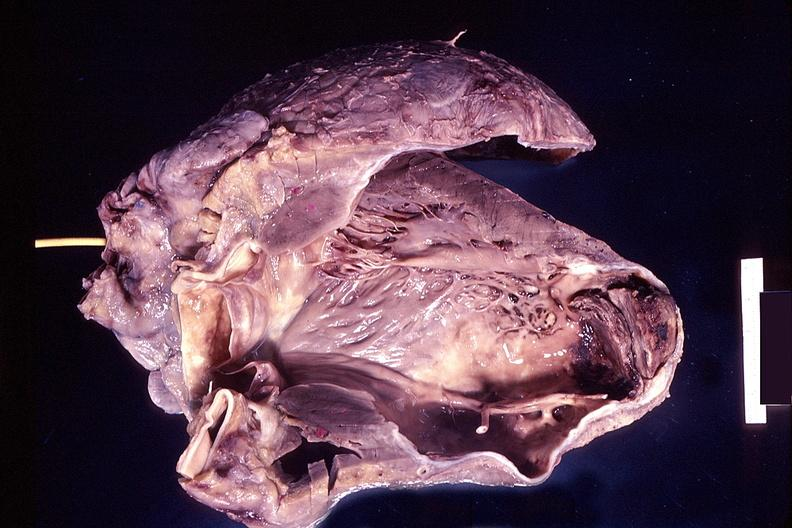does myocardium show heart, old myocardial infarction with aneurysm formation?
Answer the question using a single word or phrase. No 